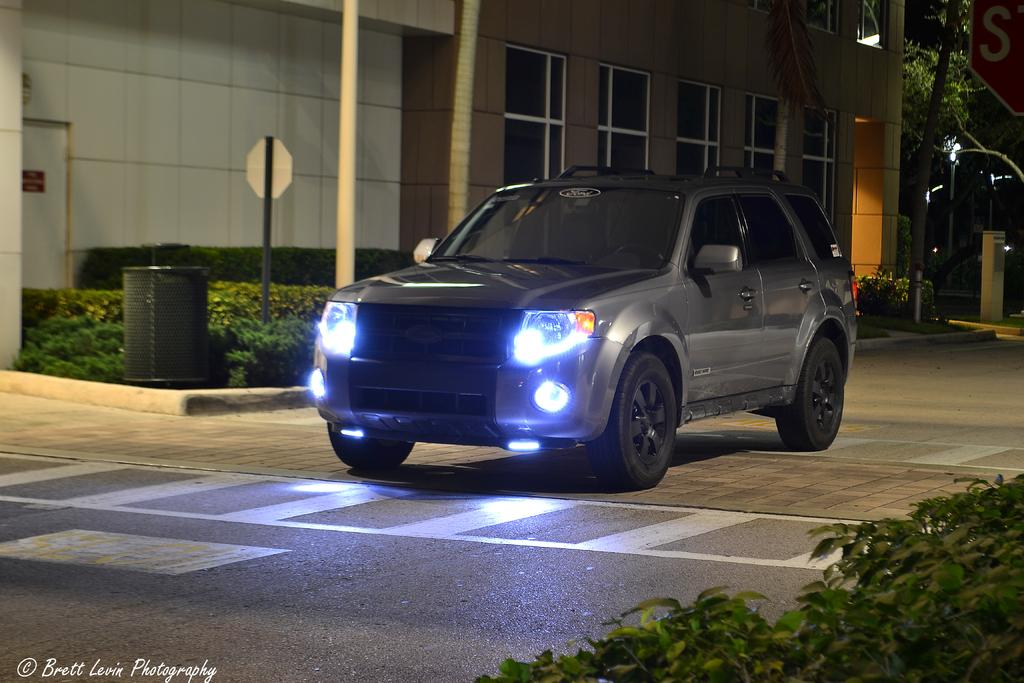What is the main subject of the image? There is a car in the image. What is the car doing in the image? The car is moving on the road. What can be seen on either side of the road? There are plants on either side of the road. What is visible in the background of the image? There is a building in the background of the image. What type of suit can be seen hanging from the car's window in the image? There is no suit visible in the image; it only features a car moving on the road with plants on either side and a building in the background. 